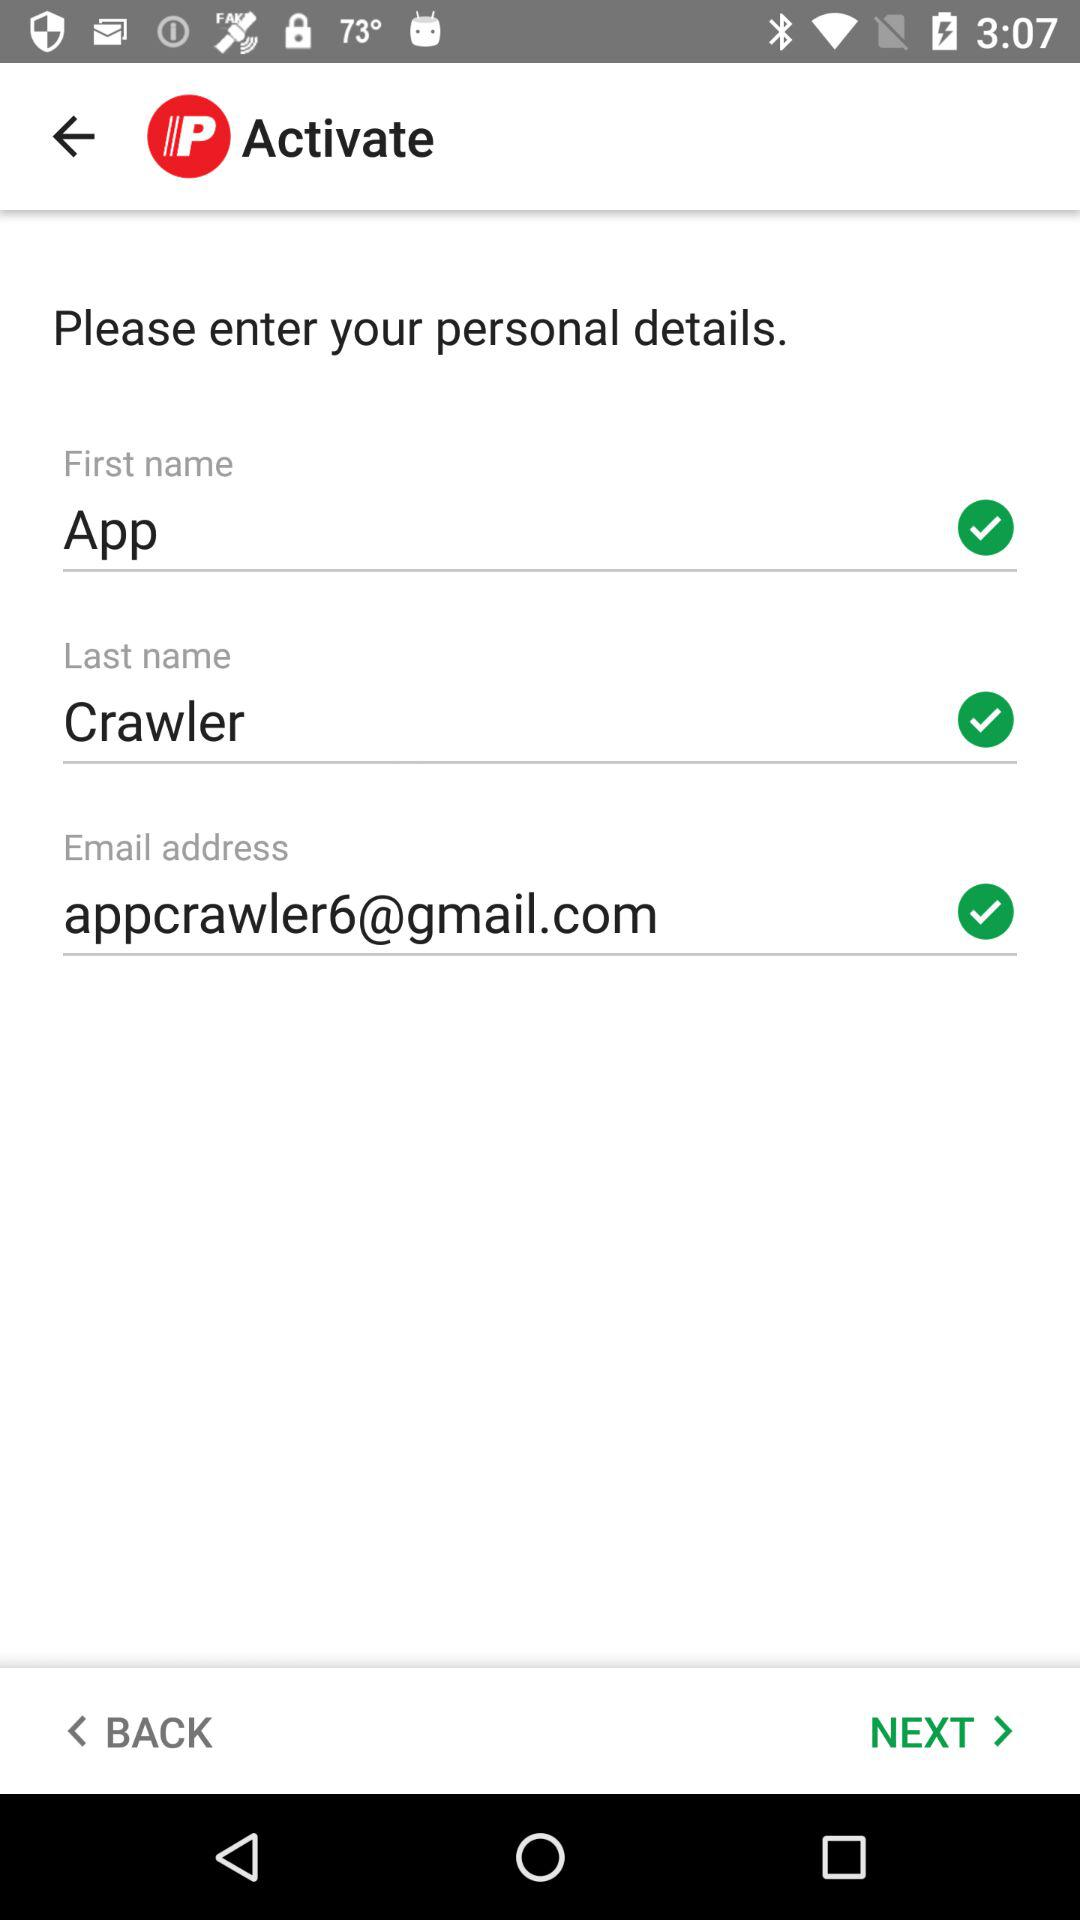What is the email address of the user? The email address of the user is appcrawler6@gmail.com. 